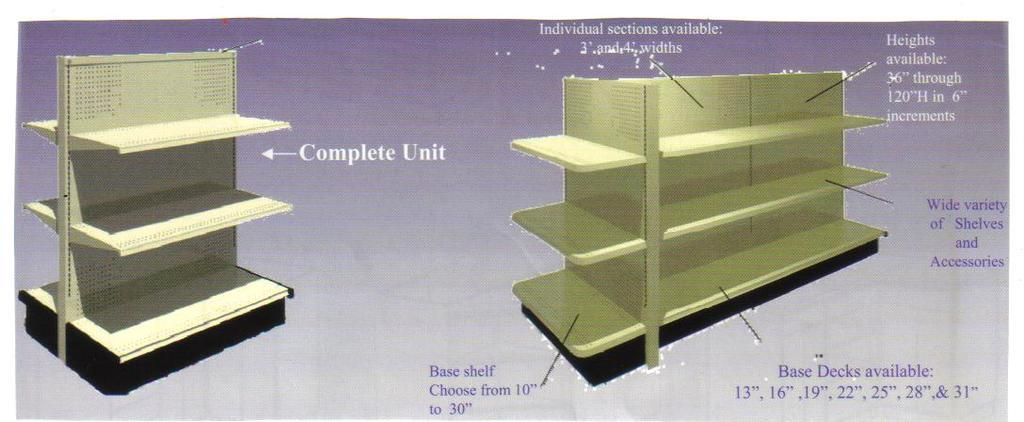<image>
Present a compact description of the photo's key features. a sign showing demensions of a complete unite shelving 